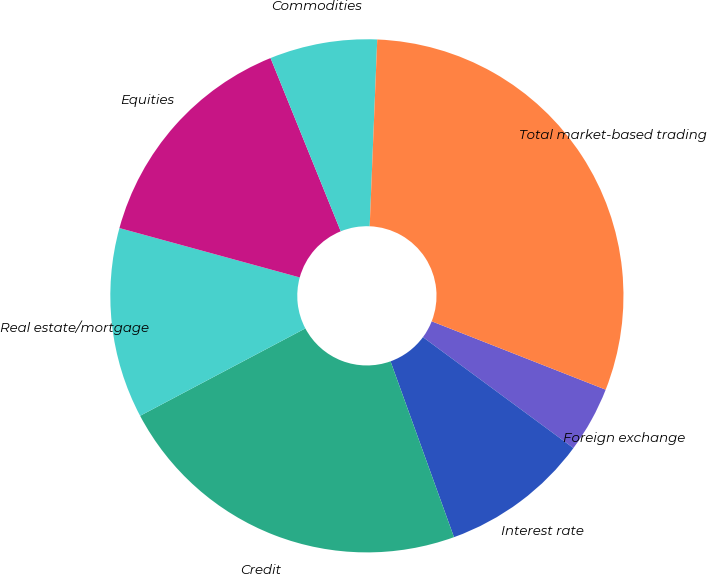<chart> <loc_0><loc_0><loc_500><loc_500><pie_chart><fcel>Foreign exchange<fcel>Interest rate<fcel>Credit<fcel>Real estate/mortgage<fcel>Equities<fcel>Commodities<fcel>Total market-based trading<nl><fcel>4.15%<fcel>9.38%<fcel>22.77%<fcel>12.0%<fcel>14.62%<fcel>6.77%<fcel>30.32%<nl></chart> 